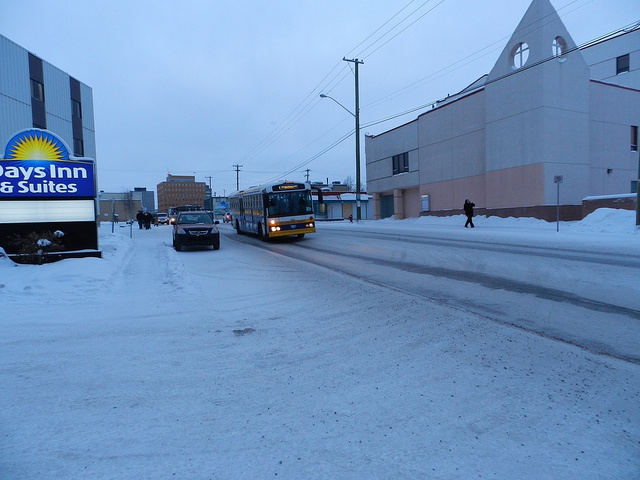Describe the objects in this image and their specific colors. I can see bus in lightblue, black, navy, blue, and gray tones, car in lightblue, black, navy, blue, and gray tones, people in lightblue, black, and gray tones, car in lightblue, black, navy, and gray tones, and people in lightblue, black, navy, blue, and gray tones in this image. 